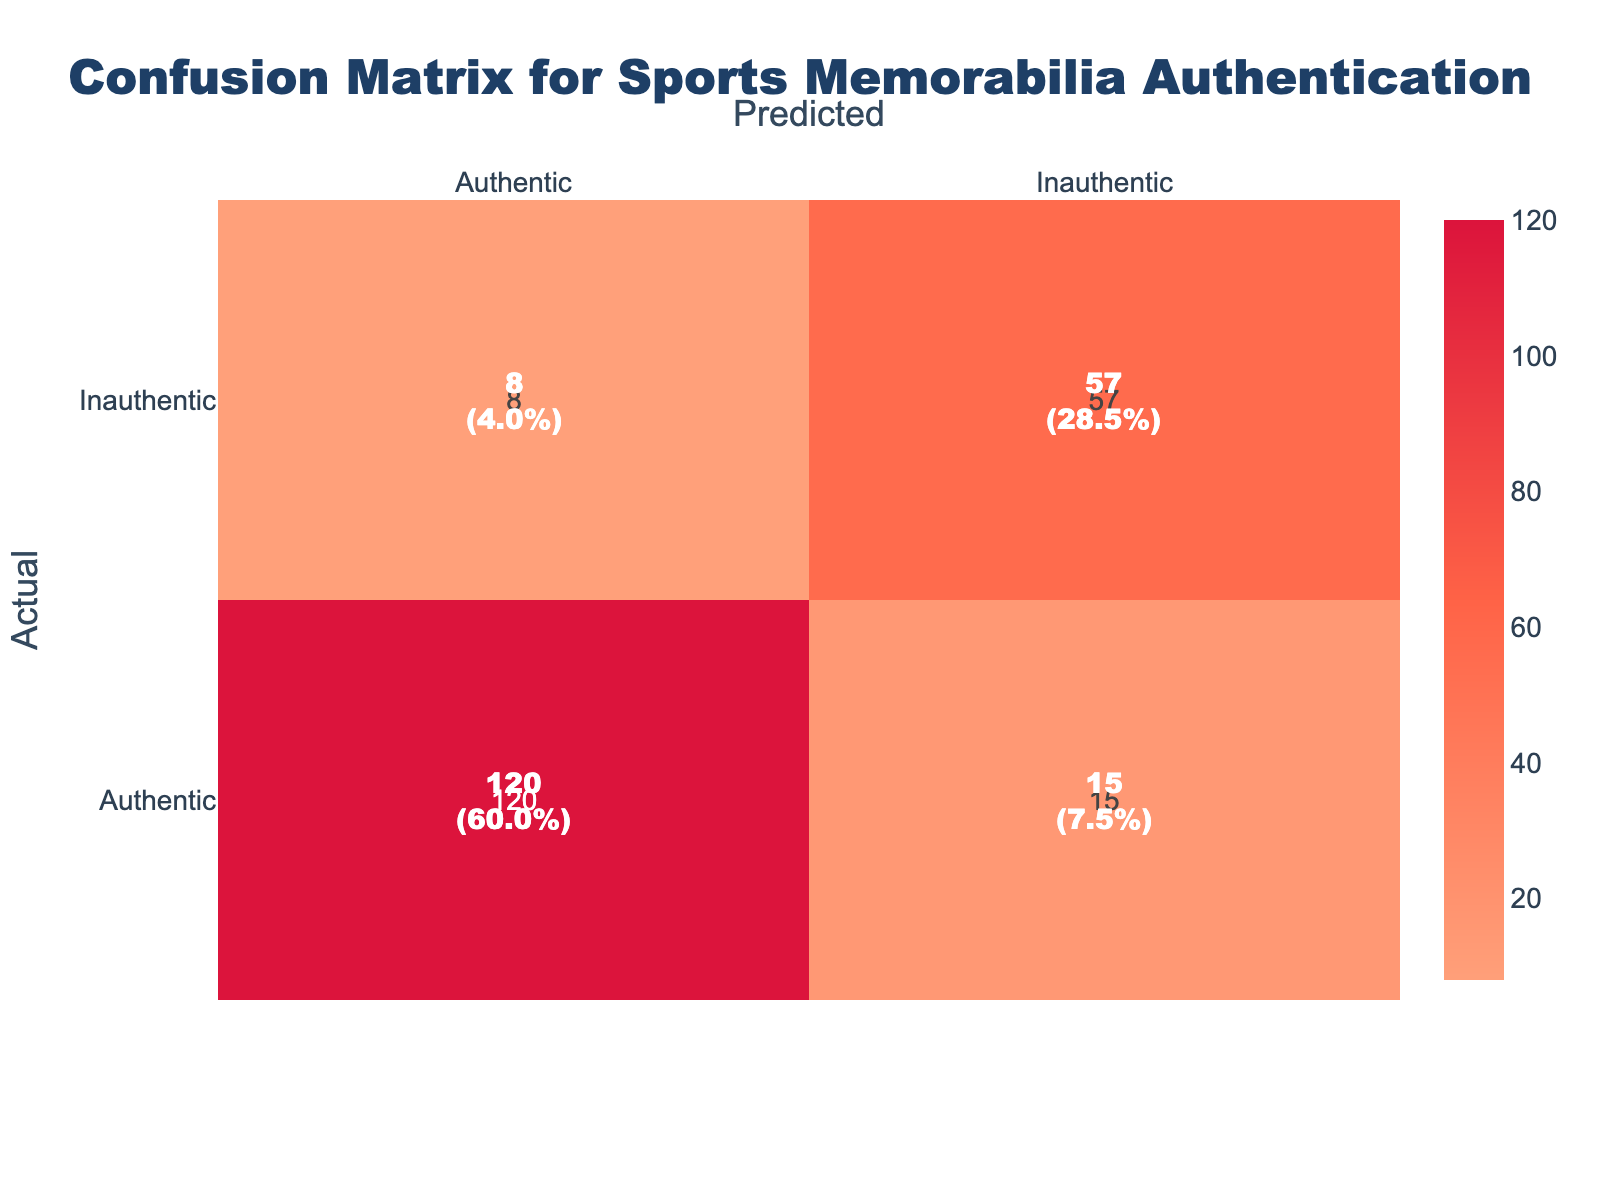What is the total number of items that were classified as authentic? To find the total number of items classified as authentic, look at the row labeled "Authentic." The counts in this row are 120 (predicted authentic) and 15 (predicted inauthentic). Adding these together gives 120 + 15 = 135.
Answer: 135 What is the total number of items that were incorrectly classified as authentic? To find the total incorrectly classified as authentic, look at the row labeled "Inauthentic." The counts here are 8 (predicted authentic) and 57 (predicted inauthentic). The incorrect classification is 8.
Answer: 8 What percentage of items were correctly identified as authentic? Start by identifying the correctly classified authentic items, which is the count in the "Authentic" row under "Authentic," which is 120. Then, divide this by the total number of items, which can be computed as 120 + 15 + 8 + 57 = 200. The percentage correct is (120/200) * 100 = 60%.
Answer: 60% How many total items were predicted as inauthentic? Check the "Inauthentic" column for predicted counts, which includes 8 (actual authentic predicted inauthentic) and 57 (actual inauthentic predicted inauthentic). Adding these gives 8 + 57 = 65.
Answer: 65 Was the overall accuracy of the model above 70%? To evaluate accuracy, calculate the total correct predictions: 120 (true positives) + 57 (true negatives) = 177. The total number of predictions is 200. The accuracy is 177/200 = 0.885 or 88.5%, which is above 70%.
Answer: Yes What is the difference between the number of authentic items correctly and incorrectly classified? The number of correctly classified authentic items is 120 (true positives) and incorrectly classified authentic items is 8 (false negatives). The difference is 120 - 8 = 112.
Answer: 112 How many inauthentic items were correctly identified? Looking at the row for "Inauthentic," the count under "Inauthentic" is 57, which represents the correctly identified inauthentic items. Therefore, there were 57 inauthentic items correctly identified.
Answer: 57 What is the ratio of correctly predicted authentic items to total predicted authentic items? The number of correctly predicted authentic items is 120, and the total predicted authentic items is 120 + 8 = 128. The ratio is 120/128 = 0.9375, which can be represented as 15:16 when simplified.
Answer: 15:16 How many total items are classified as inauthentic? Look at the row labeled "Inauthentic." The counts in this row are 8 (predicted authentic) and 57 (predicted inauthentic). Adding these together gives 8 + 57 = 65 items classified as inauthentic.
Answer: 65 